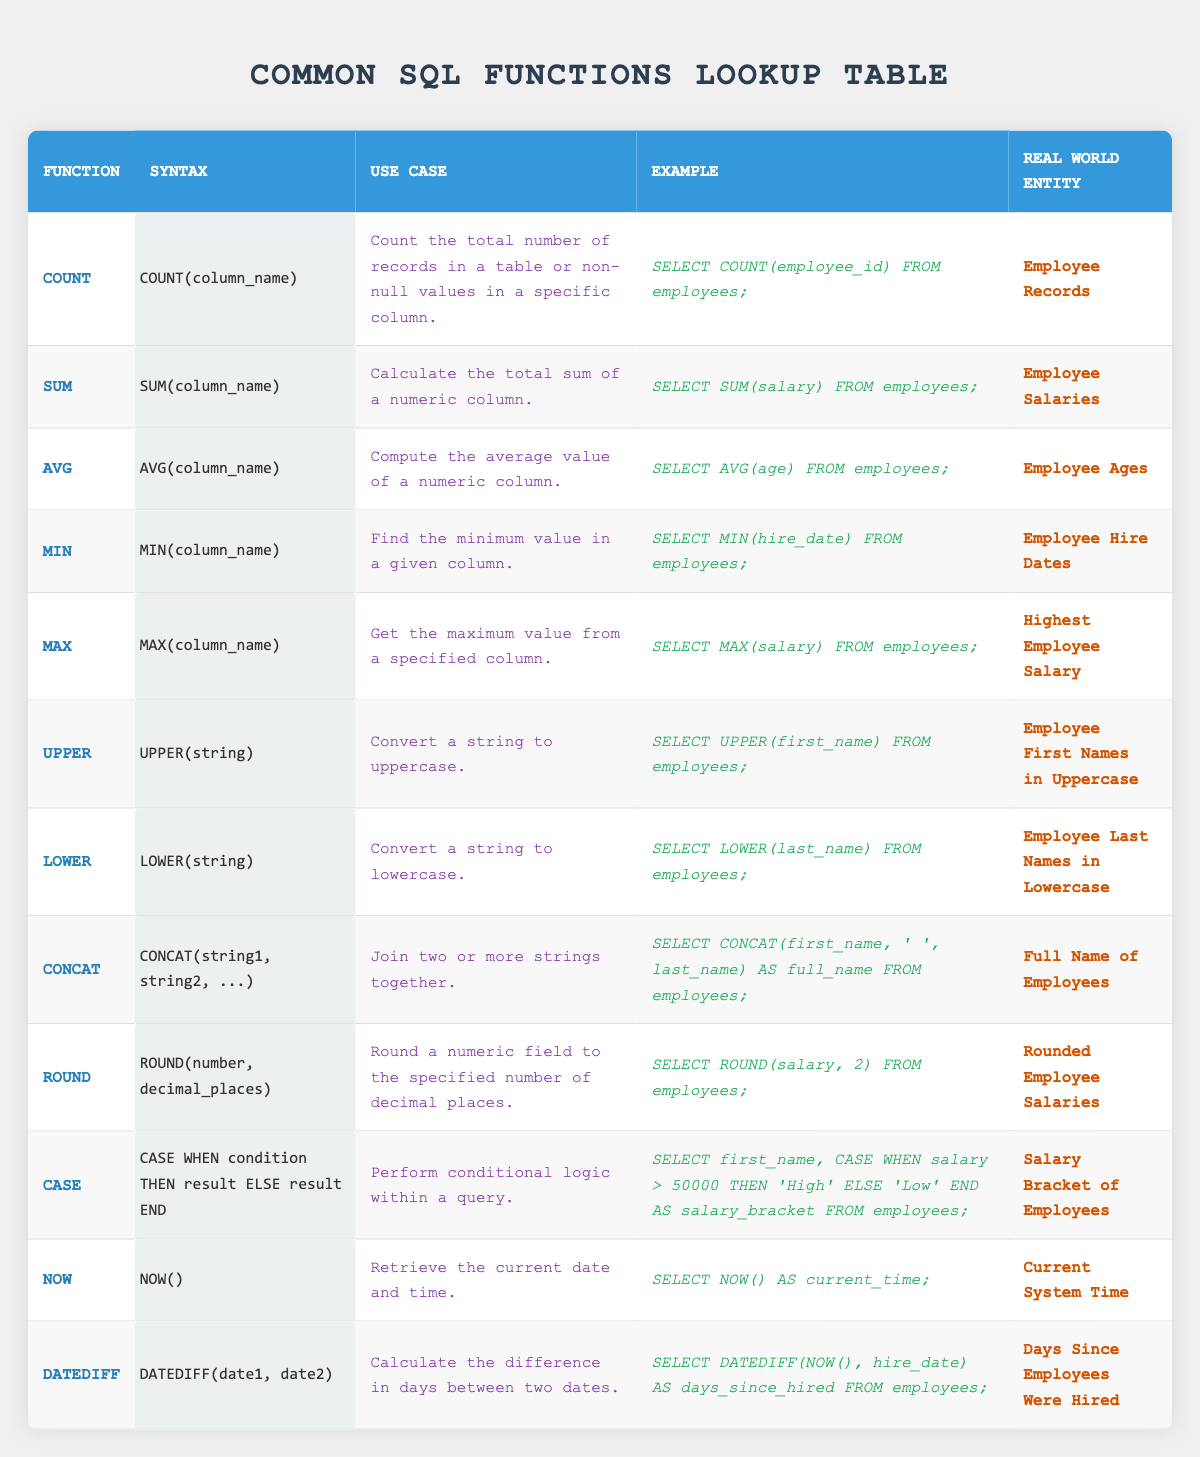What is the use case of the COUNT function? The COUNT function is used to count the total number of records in a table or the non-null values in a specific column. You can find this information clearly stated in the table under the "Use Case" column for the COUNT function.
Answer: Count total records or non-null values What is the syntax for the ROUND function? The syntax for the ROUND function is listed directly in the table; it states that the syntax is ROUND(number, decimal_places). This information can be found specifically in the "Syntax" column corresponding to the ROUND row.
Answer: ROUND(number, decimal_places) Does the AVG function have a real-world entity related to it? Yes, the AVG function is associated with the real-world entity of Employee Ages, which is mentioned in the "Real World Entity" column for the AVG function in the table.
Answer: Yes Which function allows you to convert a string to lowercase? The function that converts a string to lowercase is the LOWER function. This can be referenced from the function name in the table.
Answer: LOWER What is the maximum possible salary among employees according to the MAX function? The MAX function will return the highest employee salary, which is indicated in the "Real World Entity" column as "Highest Employee Salary." However, without exact numeric data from the table, no specific number can be provided here.
Answer: Highest Employee Salary What would be the result of using the DATEDIFF function with NOW() and hire_date? The DATEDIFF function calculates the difference in days between two dates. In this case, it calculates the number of days since employees were hired by using the current date and the hire date associated with each employee. The interpretation can be derived from the description given in the use case and real-world entity columns relevant to the DATEDIFF function.
Answer: Days Since Employees Were Hired If a salary is greater than 50,000, which result does the CASE function return? According to the CASE function in the table, if an employee's salary is greater than 50,000, then the result returned will be 'High'. This can be confirmed by examining the example provided in the table under the CASE function.
Answer: High What does the CONCAT function do? The CONCAT function joins two or more strings together, as noted in the use case description in the table. This functionality can lead to practical applications such as compiling full names from individual first and last name fields.
Answer: Joins strings together Which function would you use to find the earliest hire date among employees? To find the earliest hire date, the MIN function should be used. This is explicitly mentioned in the use case and can be assessed from the data listed under the MIN row in the table concerning employee hire dates.
Answer: MIN 